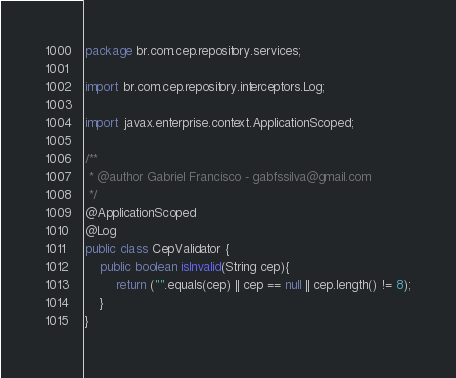<code> <loc_0><loc_0><loc_500><loc_500><_Java_>package br.com.cep.repository.services;

import br.com.cep.repository.interceptors.Log;

import javax.enterprise.context.ApplicationScoped;

/**
 * @author Gabriel Francisco - gabfssilva@gmail.com
 */
@ApplicationScoped
@Log
public class CepValidator {
    public boolean isInvalid(String cep){
        return ("".equals(cep) || cep == null || cep.length() != 8);
    }
}
</code> 